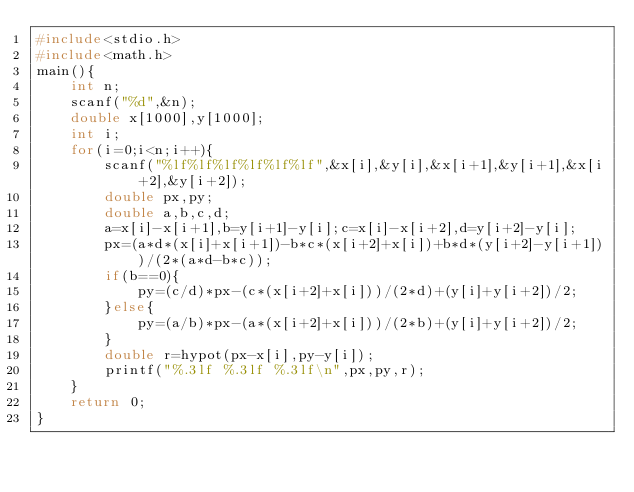<code> <loc_0><loc_0><loc_500><loc_500><_C_>#include<stdio.h>
#include<math.h>
main(){
	int n;
	scanf("%d",&n);
	double x[1000],y[1000];
	int i;
	for(i=0;i<n;i++){
		scanf("%lf%lf%lf%lf%lf%lf",&x[i],&y[i],&x[i+1],&y[i+1],&x[i+2],&y[i+2]);
		double px,py;
		double a,b,c,d;
		a=x[i]-x[i+1],b=y[i+1]-y[i];c=x[i]-x[i+2],d=y[i+2]-y[i];
		px=(a*d*(x[i]+x[i+1])-b*c*(x[i+2]+x[i])+b*d*(y[i+2]-y[i+1]))/(2*(a*d-b*c));
		if(b==0){
			py=(c/d)*px-(c*(x[i+2]+x[i]))/(2*d)+(y[i]+y[i+2])/2;
		}else{
			py=(a/b)*px-(a*(x[i+2]+x[i]))/(2*b)+(y[i]+y[i+2])/2;
		}
		double r=hypot(px-x[i],py-y[i]);
		printf("%.3lf %.3lf %.3lf\n",px,py,r);
	}
	return 0;
}</code> 